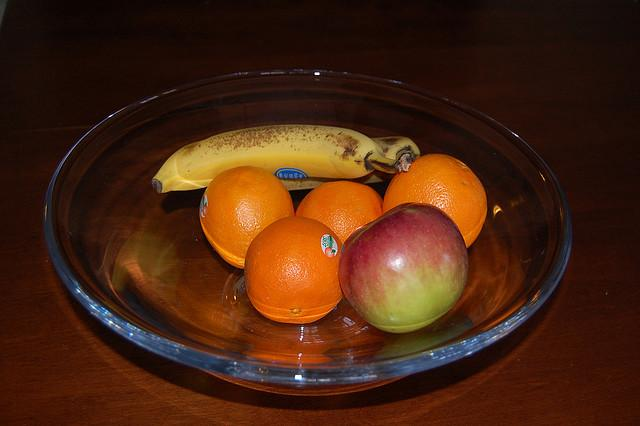What type of fruit is at the front of this fruit basket ahead of all of the oranges? apple 